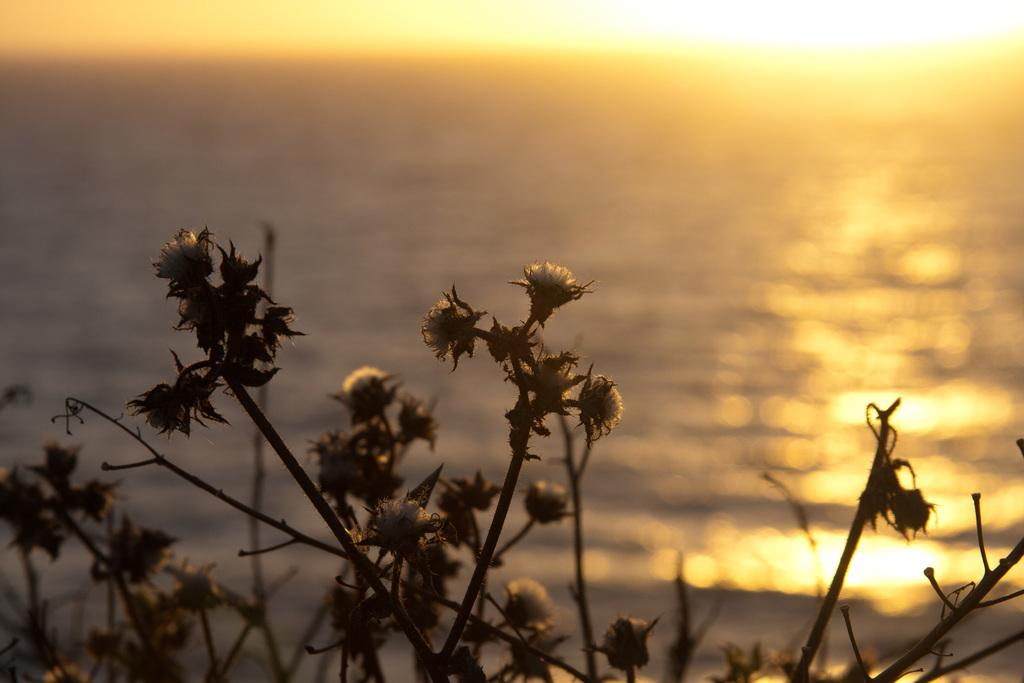What type of living organisms can be seen in the image? Plants can be seen in the image. What can be seen in the background of the image? There is water visible in the background of the image. What colors are present in the sky in the image? The sky is white and yellow in color. How many sticks can be seen in the image? There are no sticks present in the image. Are there any kittens playing with the plants in the image? There are no kittens present in the image. 